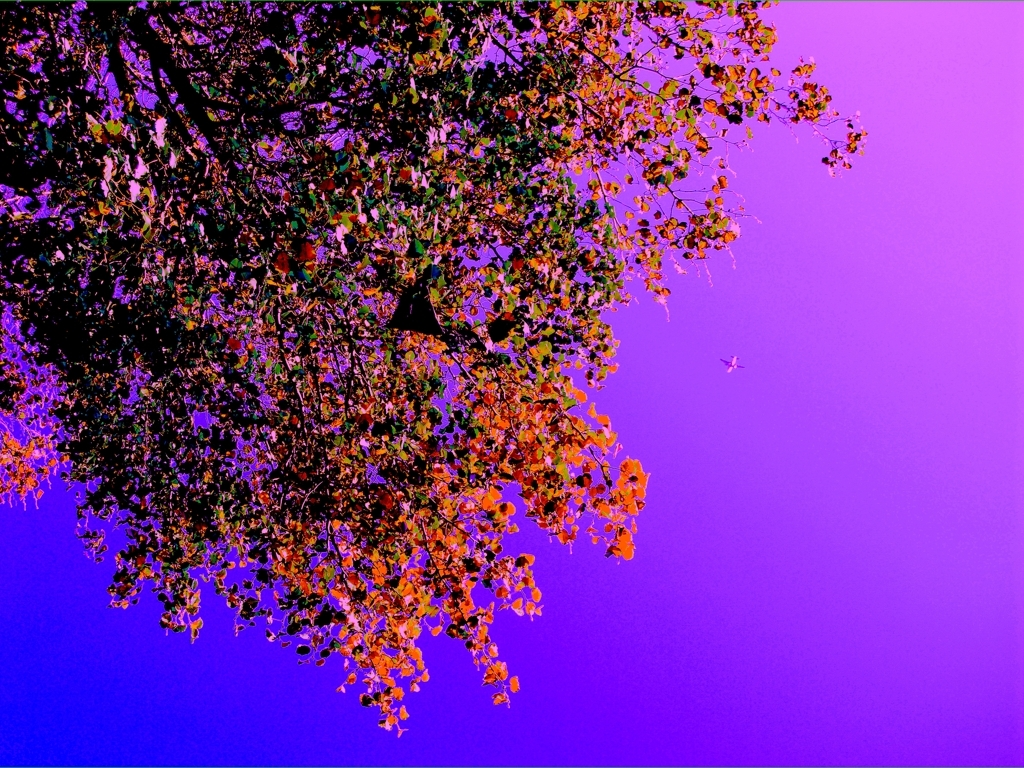Could this image be used for any special occasions or themes? Absolutely, this image with its striking colors and composition could be well suited for creative projects related to music albums, book covers, or any venture that benefits from an abstract and visually intriguing background. It could also be apt for themes such as contemplation, the unknown, or natural beauty seen through a different lens. 